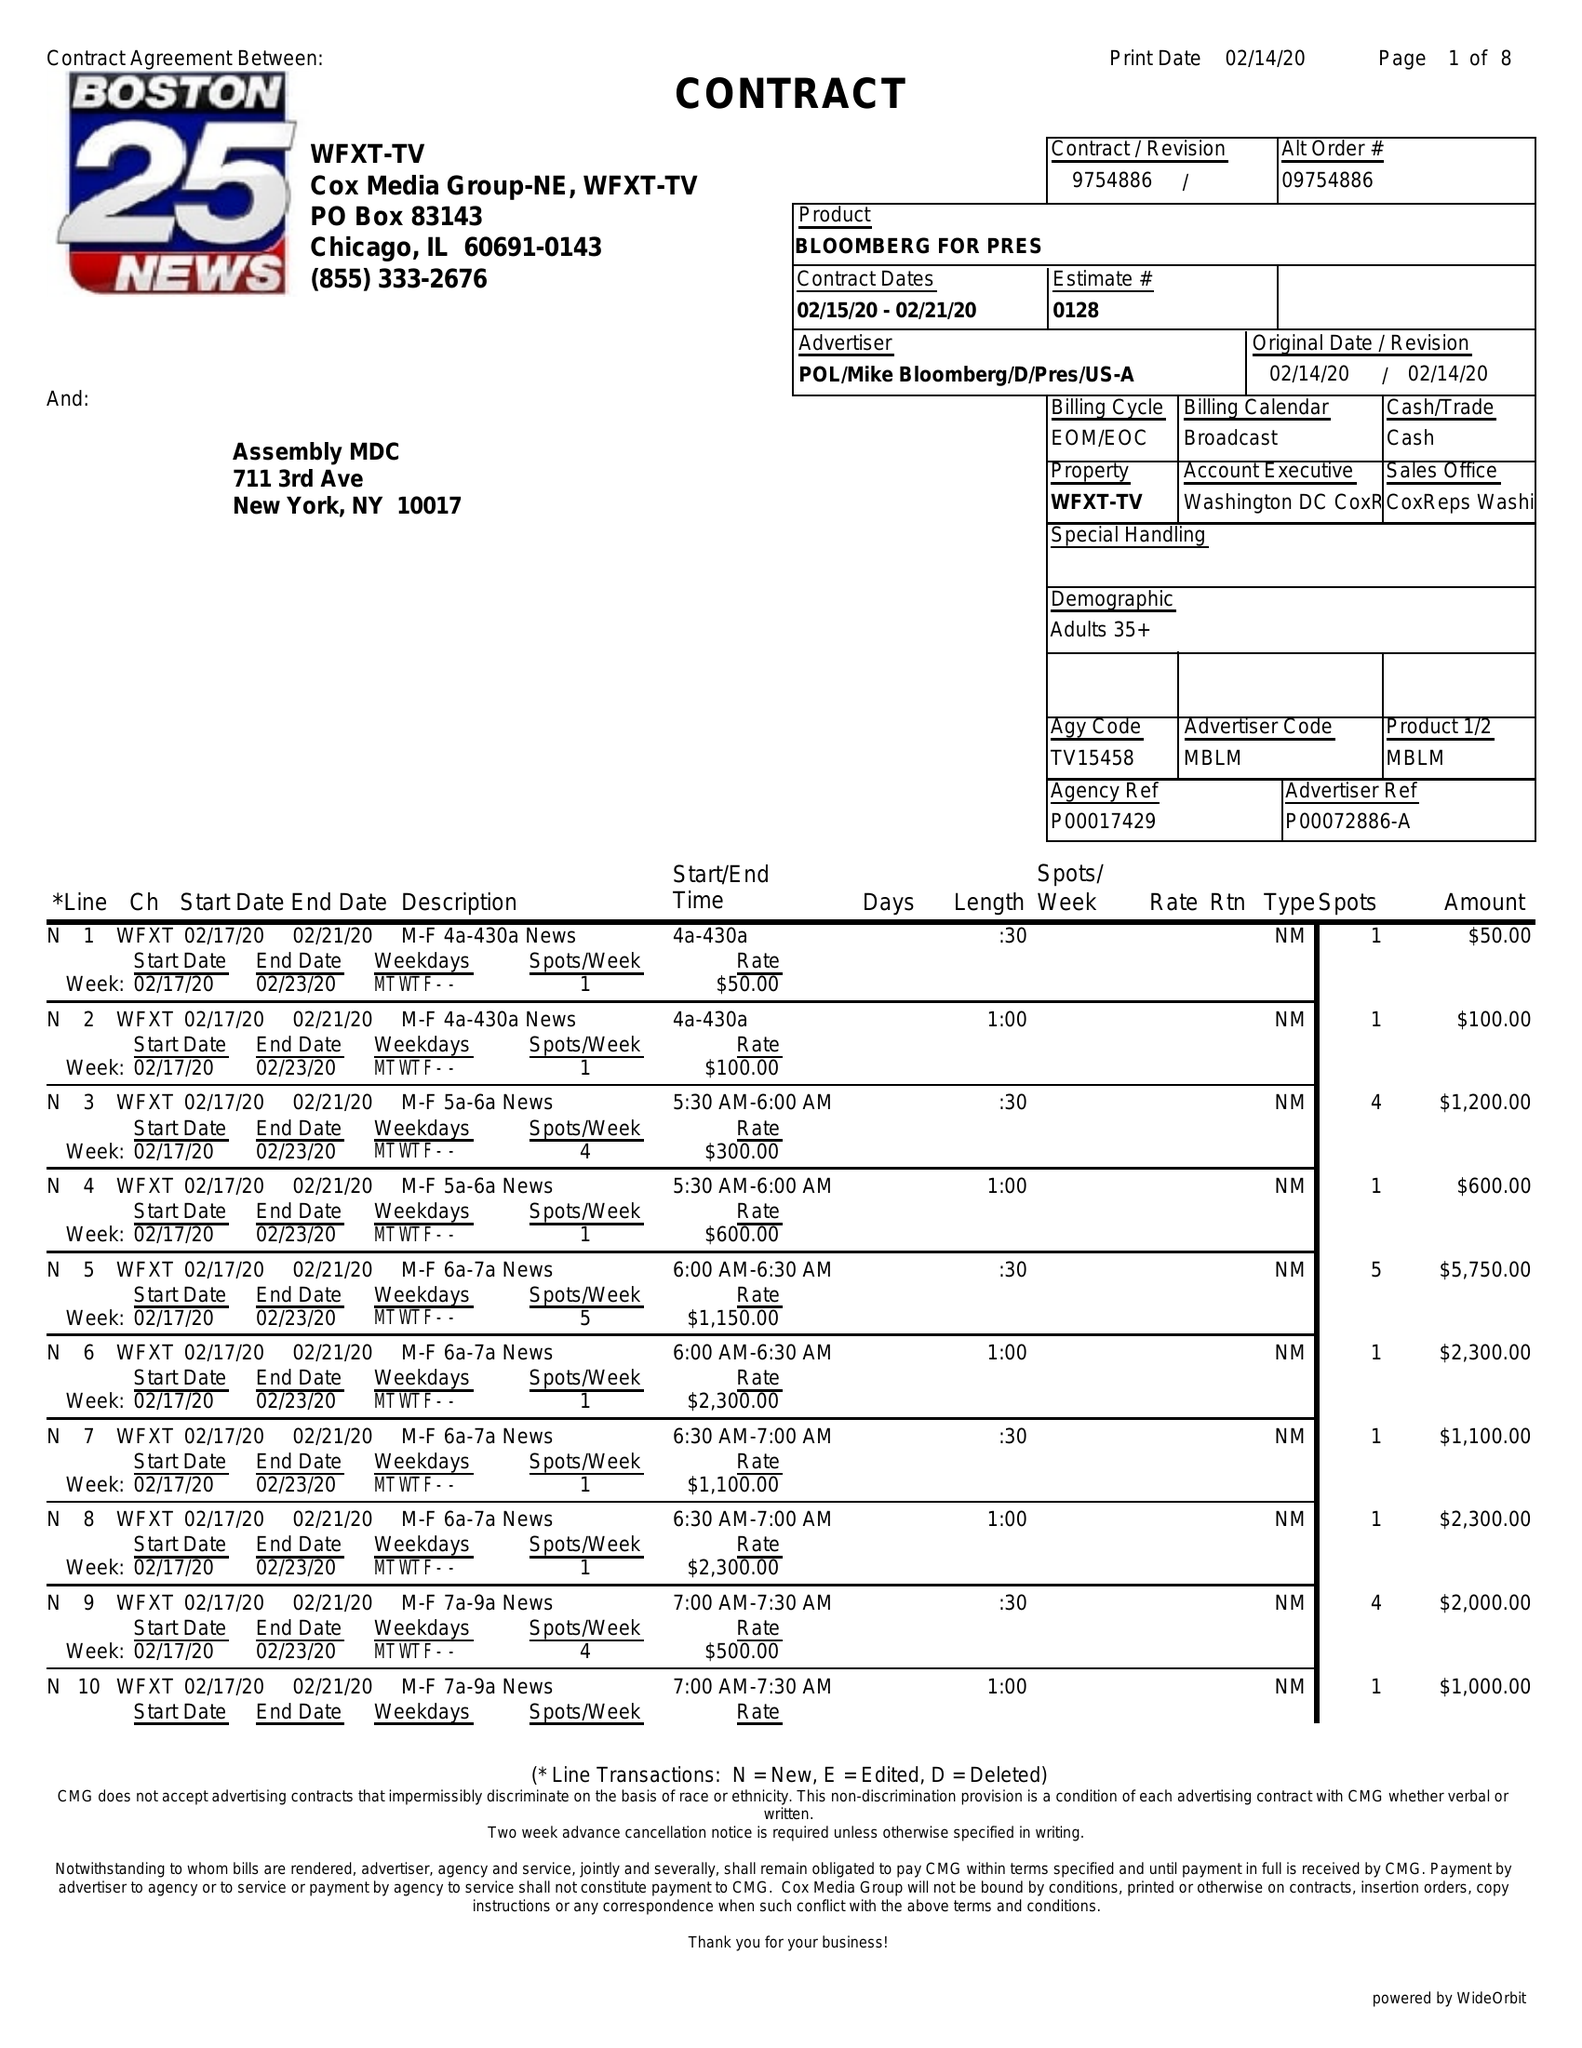What is the value for the gross_amount?
Answer the question using a single word or phrase. 210350.00 